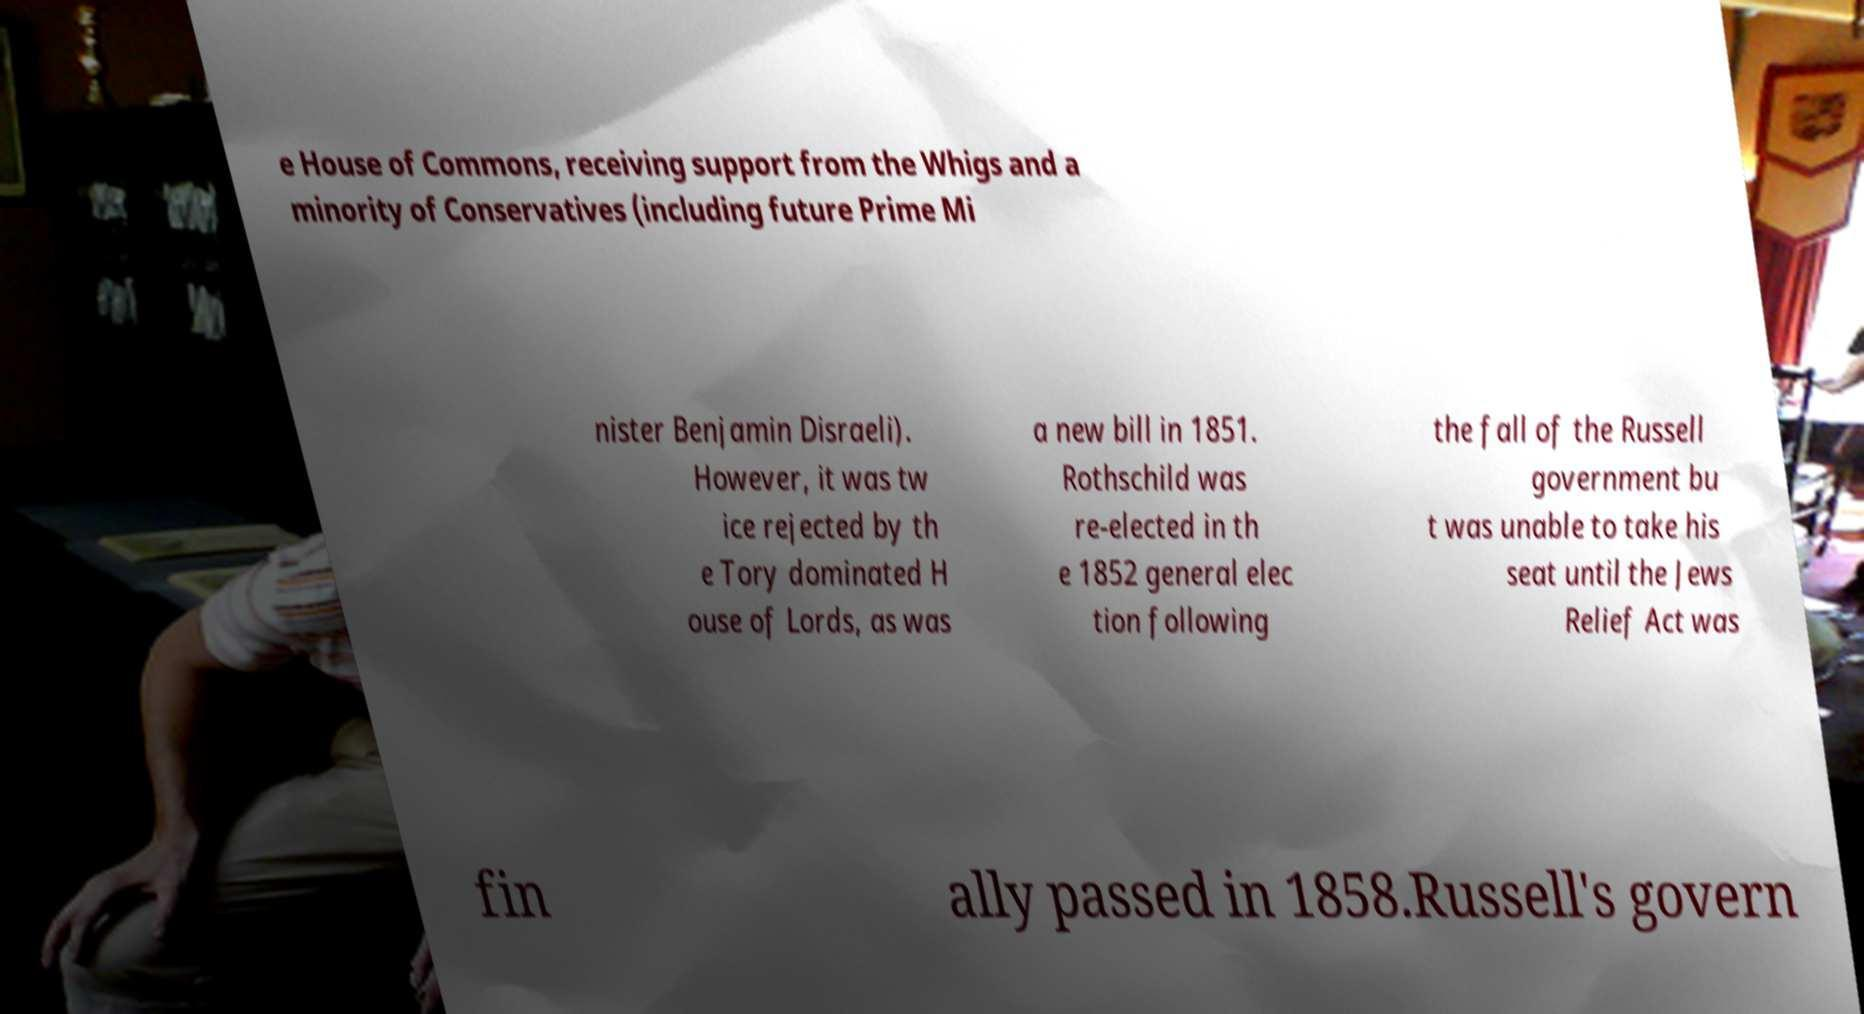Could you extract and type out the text from this image? e House of Commons, receiving support from the Whigs and a minority of Conservatives (including future Prime Mi nister Benjamin Disraeli). However, it was tw ice rejected by th e Tory dominated H ouse of Lords, as was a new bill in 1851. Rothschild was re-elected in th e 1852 general elec tion following the fall of the Russell government bu t was unable to take his seat until the Jews Relief Act was fin ally passed in 1858.Russell's govern 